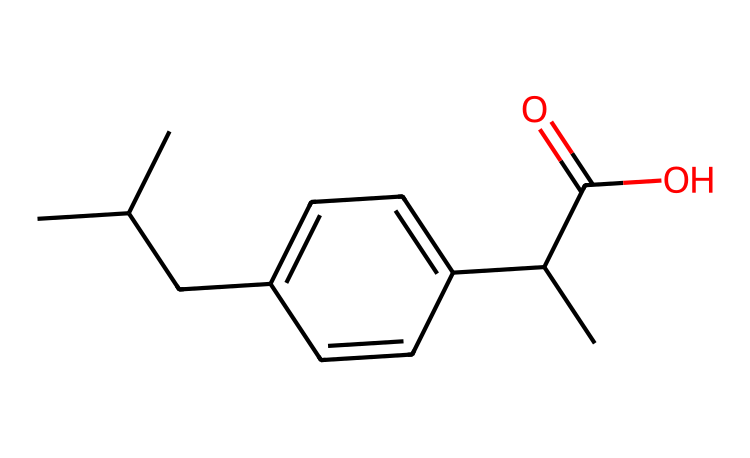How many carbon atoms are in this chemical? By examining the SMILES representation, we can count the number of carbon (C) atoms. There are 14 carbon atoms present in the structure.
Answer: 14 What functional group is present in this chemical? The chemical structure contains a carboxylic acid functional group (–COOH), as indicated by the presence of C(=O)O in the SMILES representation.
Answer: carboxylic acid Does this chemical have any ring structures? The chemical structure shows a phenyl ring (a six-membered carbon ring with alternating double bonds) as part of its composition, which is represented in the SMILES with C1=CC.
Answer: yes What is the degree of unsaturation in this chemical? The formula for degree of unsaturation (DU) is [(2C + 2 + N - H - X) / 2]. Here, C = 14, H = 20, and there is no nitrogen or halogens. Plugging in these numbers: DU = (28 + 2 - 20) / 2 = 5. This indicates five degrees of unsaturation, implying the presence of multiple double bonds or rings.
Answer: 5 Is this chemical likely to be stable under UV light exposure? The presence of unsaturation and a phenol group suggests that this chemical might undergo photochemical degradation upon exposure to UV light, making it less stable in outdoor activities.
Answer: no How many hydrogen atoms are in this chemical? In the given SMILES, by accounting for each carbon's typical bonding and adding hydrogen based on the number of unsaturations and functional groups, the total hydrogen atoms can be calculated. The total number is 20 hydrogen atoms.
Answer: 20 What type of interactions might the carboxylic acid group have in a biological system? The carboxylic acid group can form hydrogen bonds with water and proteins, facilitating solubility and interactions in biological systems. This makes it hydrophilic and reactive.
Answer: hydrogen bonds 